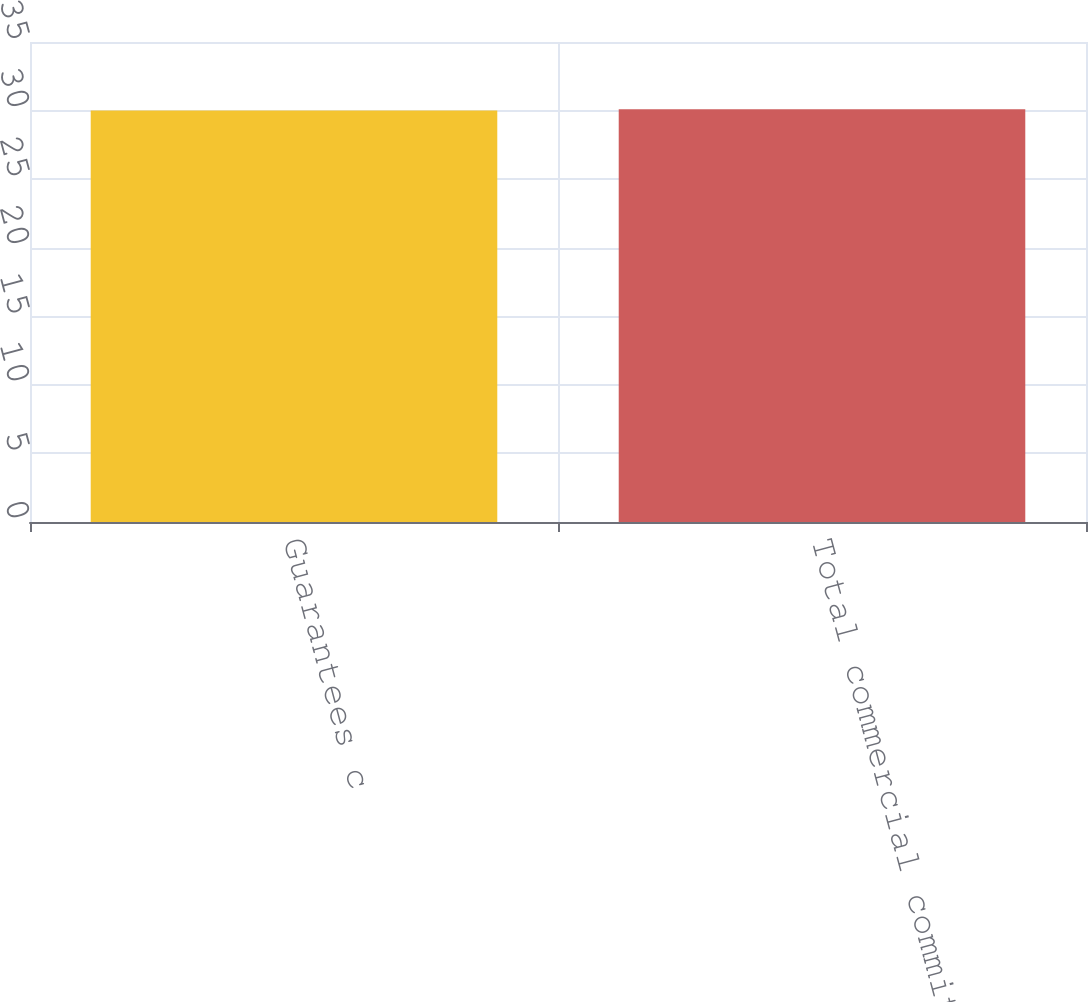Convert chart. <chart><loc_0><loc_0><loc_500><loc_500><bar_chart><fcel>Guarantees c<fcel>Total commercial commitments<nl><fcel>30<fcel>30.1<nl></chart> 